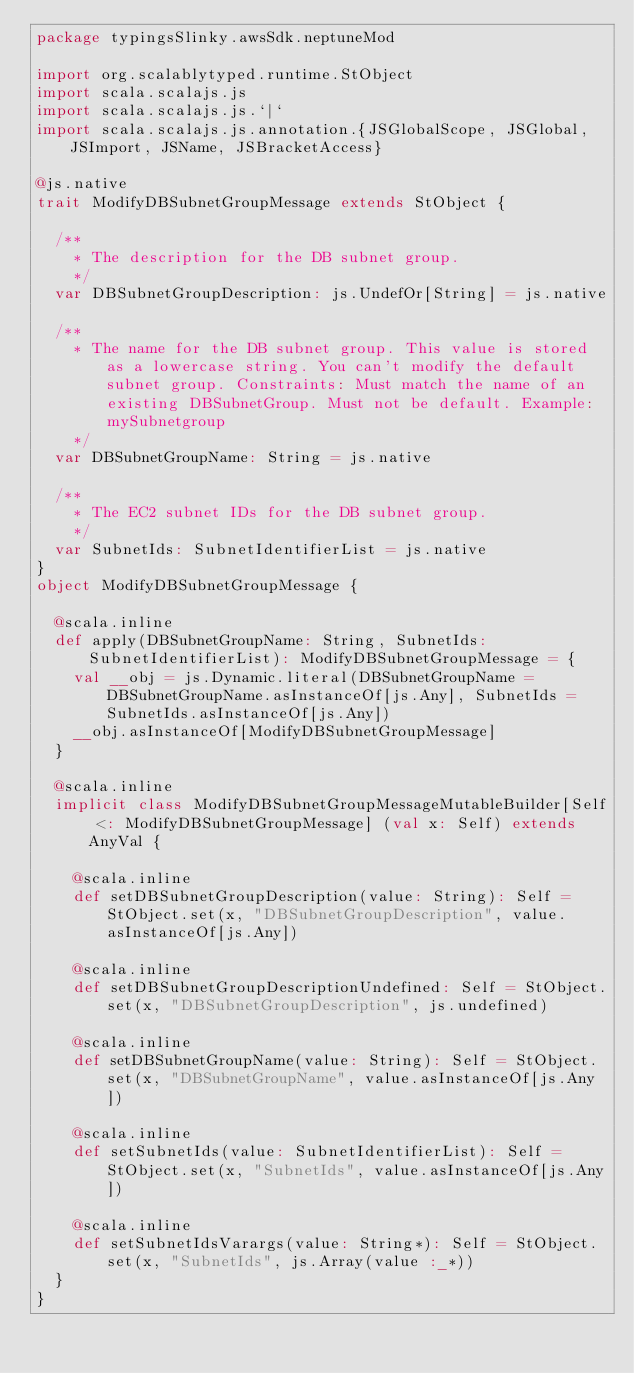<code> <loc_0><loc_0><loc_500><loc_500><_Scala_>package typingsSlinky.awsSdk.neptuneMod

import org.scalablytyped.runtime.StObject
import scala.scalajs.js
import scala.scalajs.js.`|`
import scala.scalajs.js.annotation.{JSGlobalScope, JSGlobal, JSImport, JSName, JSBracketAccess}

@js.native
trait ModifyDBSubnetGroupMessage extends StObject {
  
  /**
    * The description for the DB subnet group.
    */
  var DBSubnetGroupDescription: js.UndefOr[String] = js.native
  
  /**
    * The name for the DB subnet group. This value is stored as a lowercase string. You can't modify the default subnet group. Constraints: Must match the name of an existing DBSubnetGroup. Must not be default. Example: mySubnetgroup 
    */
  var DBSubnetGroupName: String = js.native
  
  /**
    * The EC2 subnet IDs for the DB subnet group.
    */
  var SubnetIds: SubnetIdentifierList = js.native
}
object ModifyDBSubnetGroupMessage {
  
  @scala.inline
  def apply(DBSubnetGroupName: String, SubnetIds: SubnetIdentifierList): ModifyDBSubnetGroupMessage = {
    val __obj = js.Dynamic.literal(DBSubnetGroupName = DBSubnetGroupName.asInstanceOf[js.Any], SubnetIds = SubnetIds.asInstanceOf[js.Any])
    __obj.asInstanceOf[ModifyDBSubnetGroupMessage]
  }
  
  @scala.inline
  implicit class ModifyDBSubnetGroupMessageMutableBuilder[Self <: ModifyDBSubnetGroupMessage] (val x: Self) extends AnyVal {
    
    @scala.inline
    def setDBSubnetGroupDescription(value: String): Self = StObject.set(x, "DBSubnetGroupDescription", value.asInstanceOf[js.Any])
    
    @scala.inline
    def setDBSubnetGroupDescriptionUndefined: Self = StObject.set(x, "DBSubnetGroupDescription", js.undefined)
    
    @scala.inline
    def setDBSubnetGroupName(value: String): Self = StObject.set(x, "DBSubnetGroupName", value.asInstanceOf[js.Any])
    
    @scala.inline
    def setSubnetIds(value: SubnetIdentifierList): Self = StObject.set(x, "SubnetIds", value.asInstanceOf[js.Any])
    
    @scala.inline
    def setSubnetIdsVarargs(value: String*): Self = StObject.set(x, "SubnetIds", js.Array(value :_*))
  }
}
</code> 